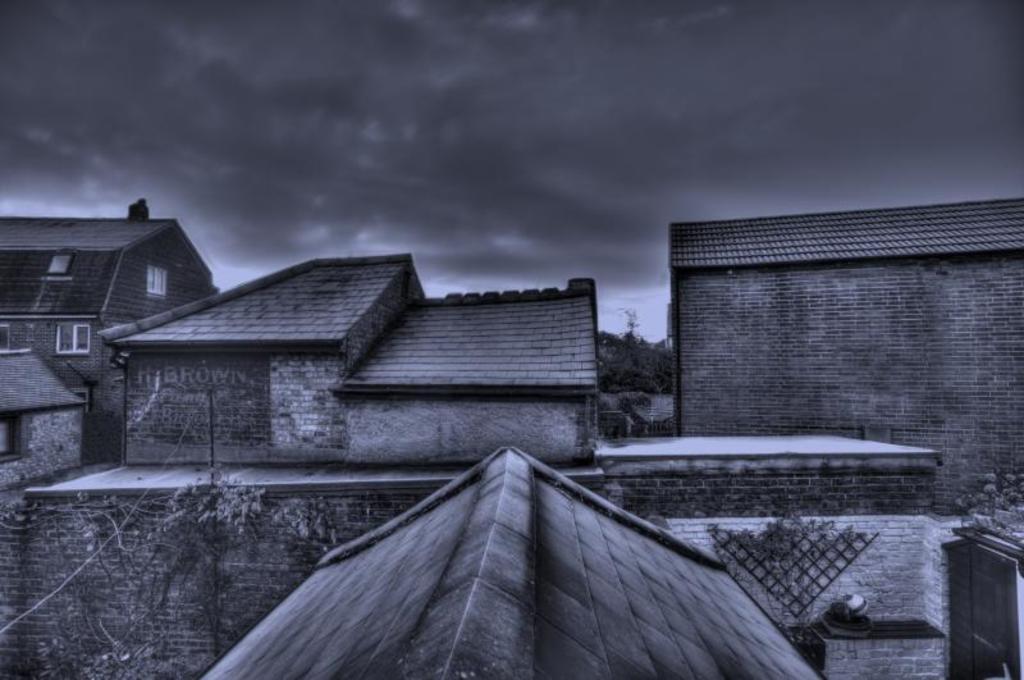Describe this image in one or two sentences. This is a black and white image. There are a few houses, trees and a pole with a wire. We can also see the sky with clouds. We can also see some objects on the right. We can also see some text on the wall. 